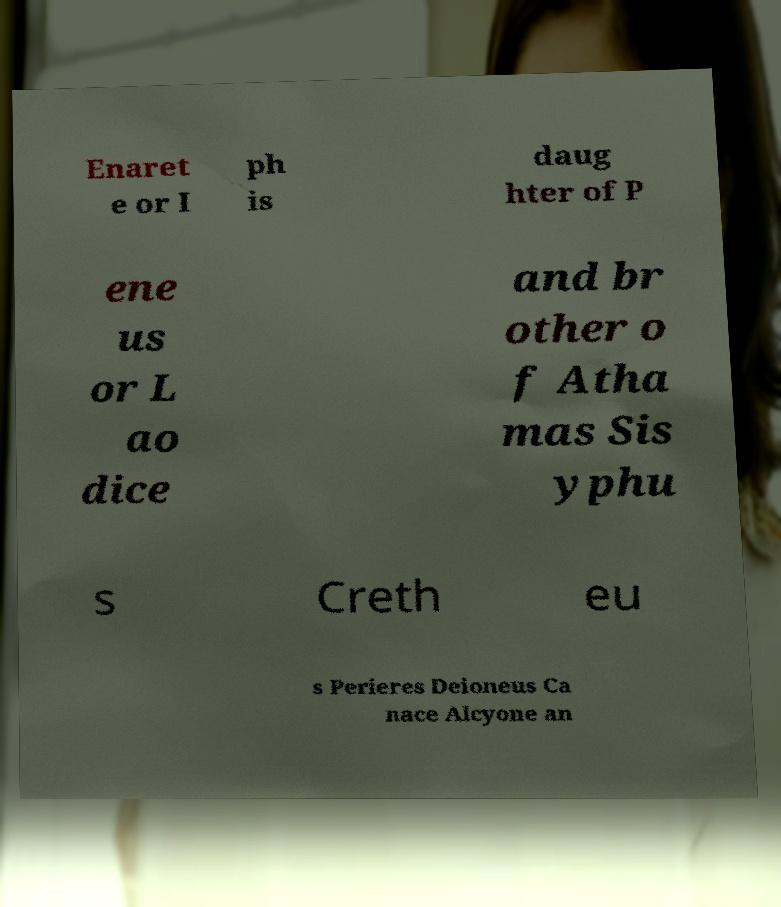For documentation purposes, I need the text within this image transcribed. Could you provide that? Enaret e or I ph is daug hter of P ene us or L ao dice and br other o f Atha mas Sis yphu s Creth eu s Perieres Deioneus Ca nace Alcyone an 